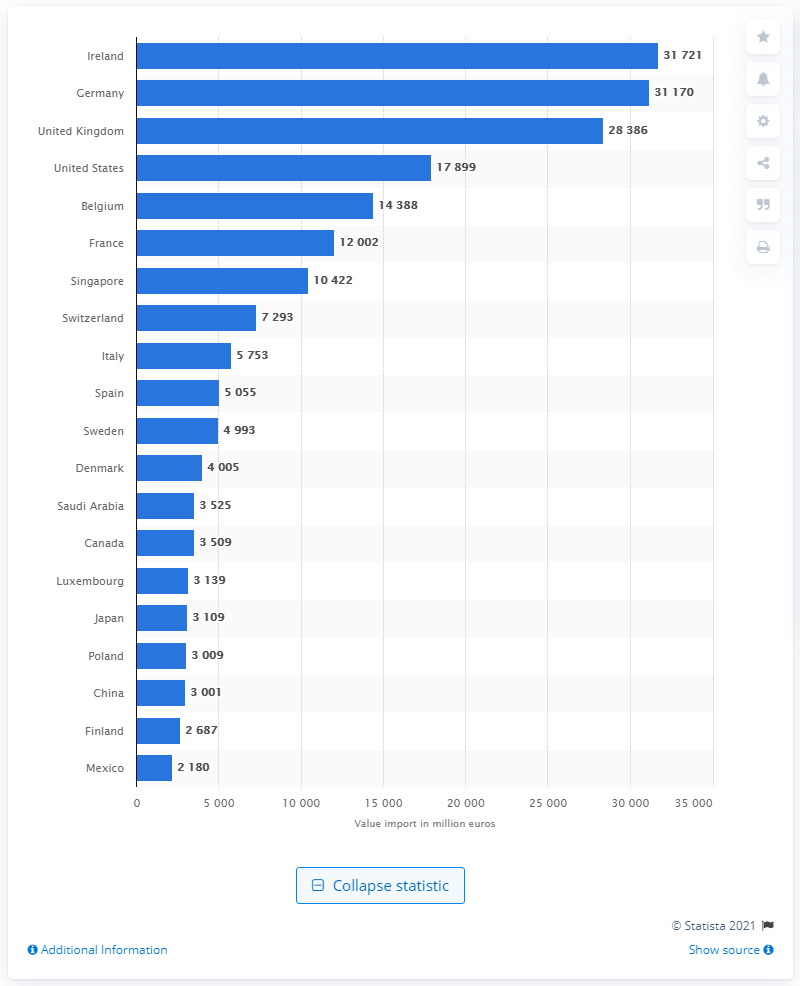How does the value of service exports to the U.S. compare to that of Germany? The value of service exports to the U.S., at 17,899 million euros, is significantly lower than that to Germany, which stands at 31,170 million euros as of 2021, making Germany the top destination in this graph. 